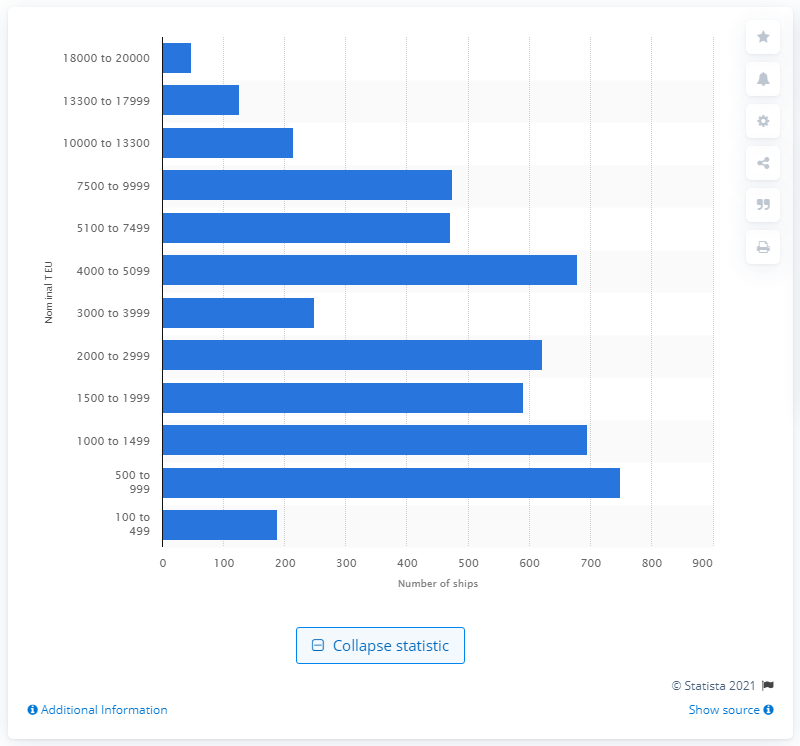Indicate a few pertinent items in this graphic. As of December 31, 2016, ship operators had 47 ships in their fleet. 